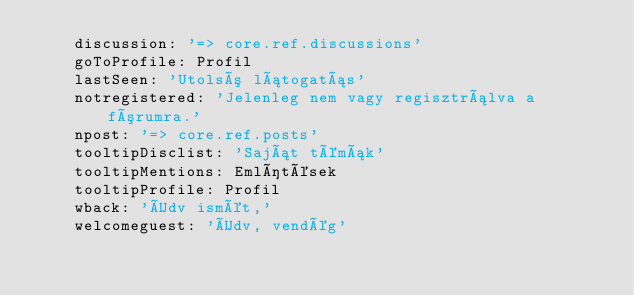<code> <loc_0><loc_0><loc_500><loc_500><_YAML_>    discussion: '=> core.ref.discussions'
    goToProfile: Profil
    lastSeen: 'Utolsó látogatás'
    notregistered: 'Jelenleg nem vagy regisztrálva a fórumra.'
    npost: '=> core.ref.posts'
    tooltipDisclist: 'Saját témák'
    tooltipMentions: Említések
    tooltipProfile: Profil
    wback: 'Üdv ismét,'
    welcomeguest: 'Üdv, vendég'
</code> 